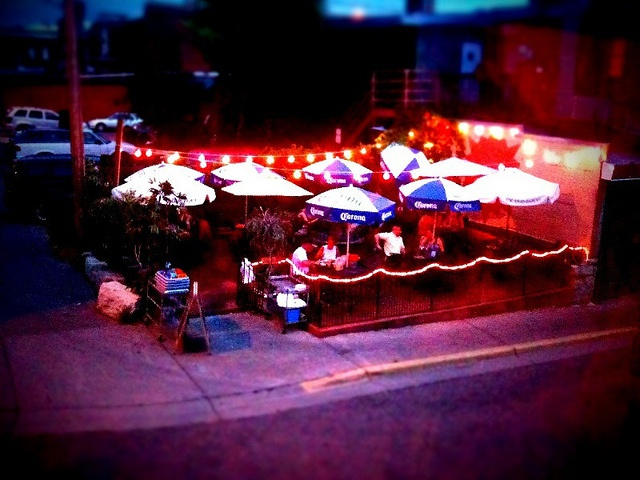Describe the objects in this image and their specific colors. I can see car in black, navy, and blue tones, umbrella in black, white, darkblue, violet, and purple tones, umbrella in black, white, violet, and lightpink tones, umbrella in black, white, maroon, and darkgray tones, and umbrella in black, white, blue, and navy tones in this image. 